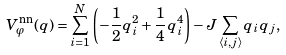<formula> <loc_0><loc_0><loc_500><loc_500>V _ { \varphi } ^ { \text {nn} } ( q ) = \sum _ { i = 1 } ^ { N } \left ( - \frac { 1 } { 2 } q _ { i } ^ { 2 } + \frac { 1 } { 4 } q _ { i } ^ { 4 } \right ) - J \sum _ { \langle i , j \rangle } q _ { i } q _ { j } ,</formula> 